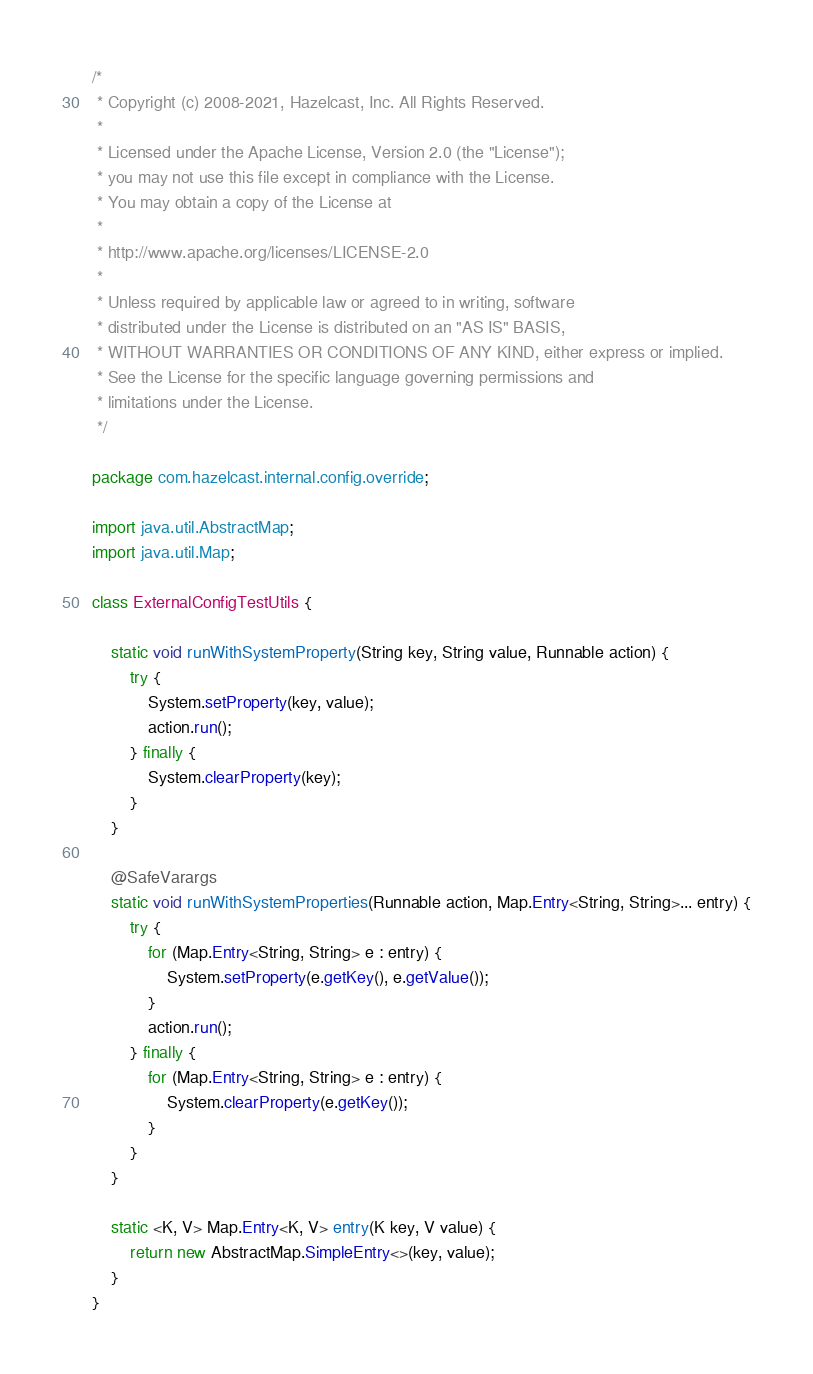Convert code to text. <code><loc_0><loc_0><loc_500><loc_500><_Java_>/*
 * Copyright (c) 2008-2021, Hazelcast, Inc. All Rights Reserved.
 *
 * Licensed under the Apache License, Version 2.0 (the "License");
 * you may not use this file except in compliance with the License.
 * You may obtain a copy of the License at
 *
 * http://www.apache.org/licenses/LICENSE-2.0
 *
 * Unless required by applicable law or agreed to in writing, software
 * distributed under the License is distributed on an "AS IS" BASIS,
 * WITHOUT WARRANTIES OR CONDITIONS OF ANY KIND, either express or implied.
 * See the License for the specific language governing permissions and
 * limitations under the License.
 */

package com.hazelcast.internal.config.override;

import java.util.AbstractMap;
import java.util.Map;

class ExternalConfigTestUtils {

    static void runWithSystemProperty(String key, String value, Runnable action) {
        try {
            System.setProperty(key, value);
            action.run();
        } finally {
            System.clearProperty(key);
        }
    }

    @SafeVarargs
    static void runWithSystemProperties(Runnable action, Map.Entry<String, String>... entry) {
        try {
            for (Map.Entry<String, String> e : entry) {
                System.setProperty(e.getKey(), e.getValue());
            }
            action.run();
        } finally {
            for (Map.Entry<String, String> e : entry) {
                System.clearProperty(e.getKey());
            }
        }
    }

    static <K, V> Map.Entry<K, V> entry(K key, V value) {
        return new AbstractMap.SimpleEntry<>(key, value);
    }
}
</code> 